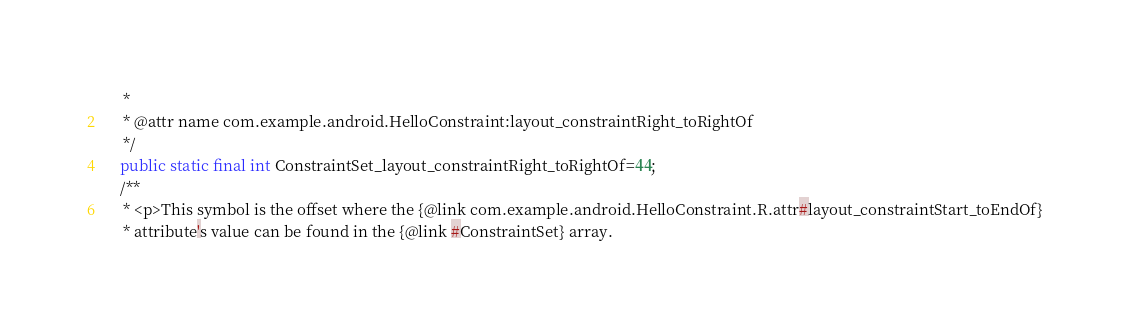<code> <loc_0><loc_0><loc_500><loc_500><_Java_>     *
     * @attr name com.example.android.HelloConstraint:layout_constraintRight_toRightOf
     */
    public static final int ConstraintSet_layout_constraintRight_toRightOf=44;
    /**
     * <p>This symbol is the offset where the {@link com.example.android.HelloConstraint.R.attr#layout_constraintStart_toEndOf}
     * attribute's value can be found in the {@link #ConstraintSet} array.</code> 